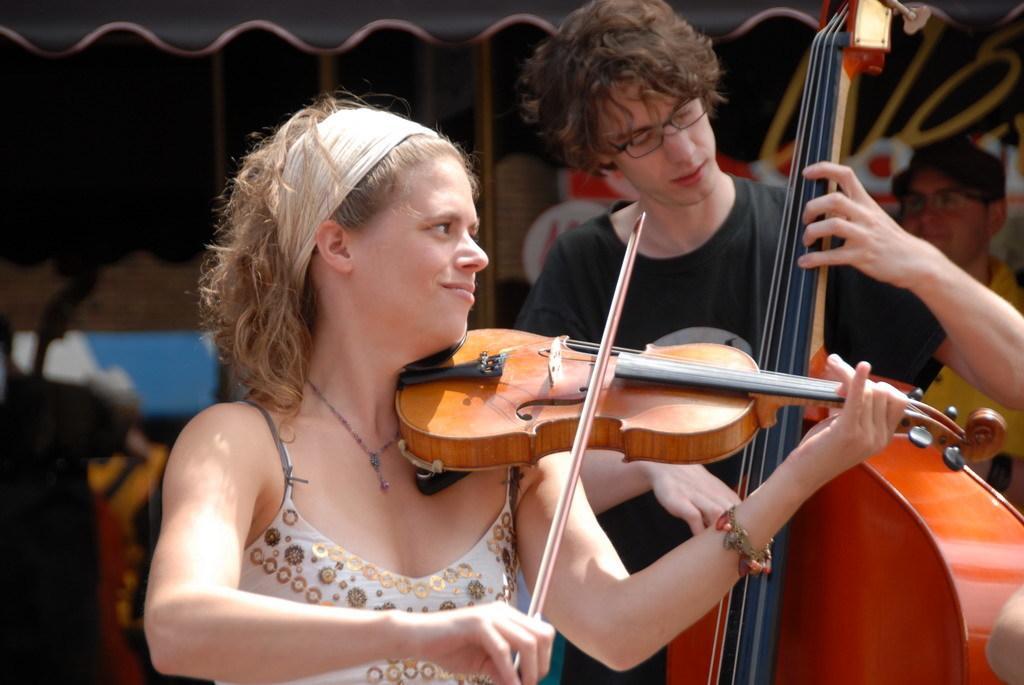Describe this image in one or two sentences. In the given image we can see a girl and a boy both are holding a musical instrument in their hands. 